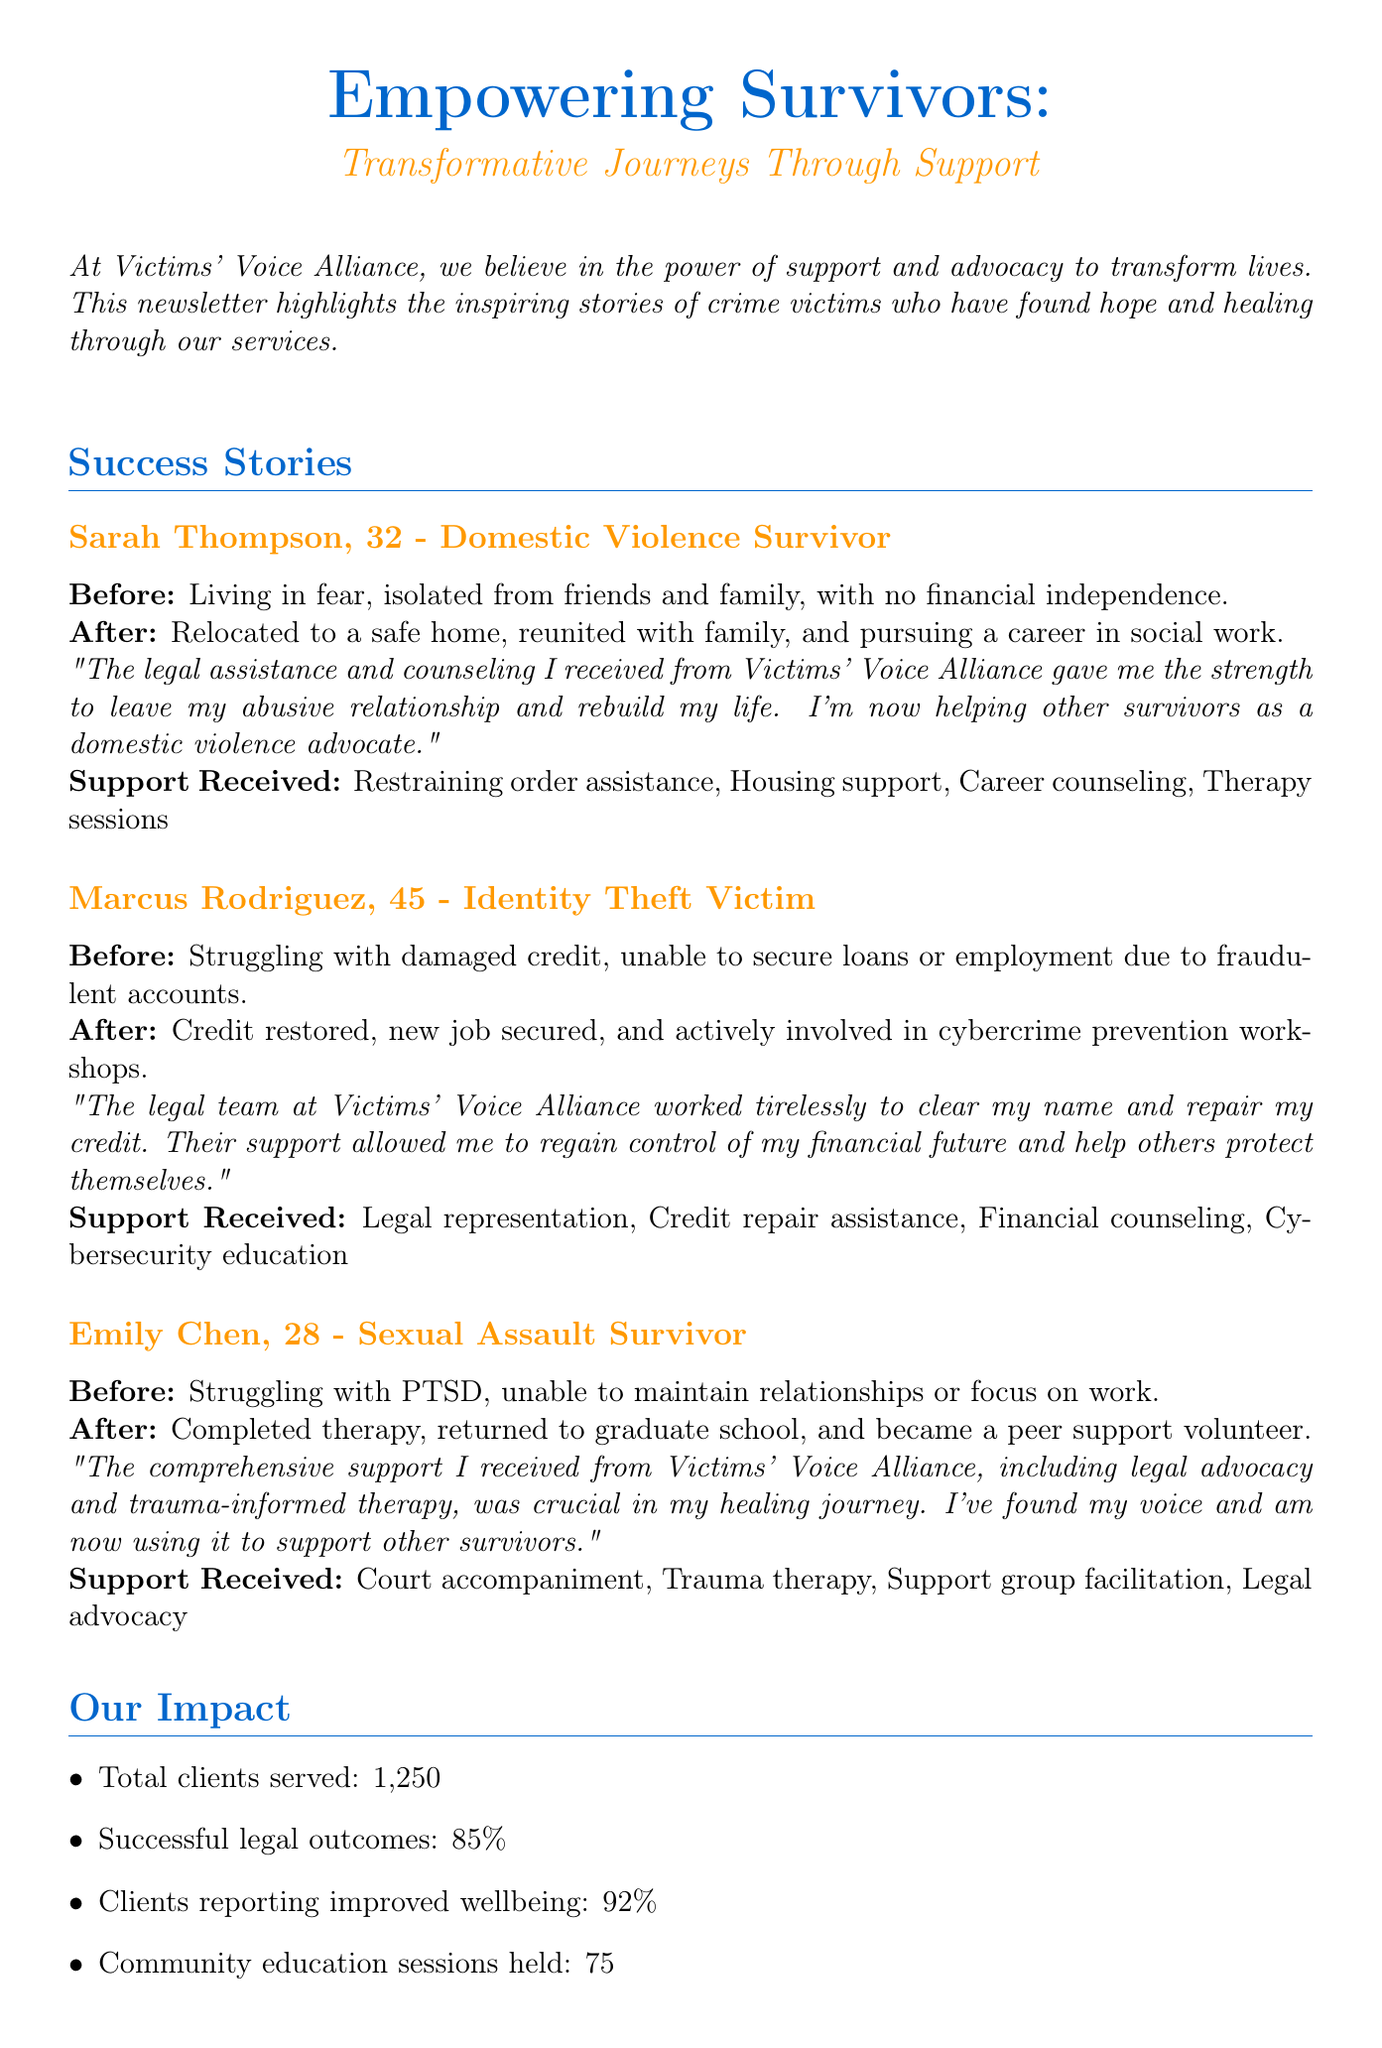What is the newsletter title? The newsletter title is mentioned at the top of the document's content.
Answer: Empowering Survivors: Transformative Journeys Through Support Who is a domestic violence survivor mentioned in the newsletter? The success stories highlight individuals who received support.
Answer: Sarah Thompson What age is Emily Chen? The age of Emily Chen is specified in the success stories section.
Answer: 28 What percentage of clients reported improved wellbeing? The impact statistics section provides specific percentages about client outcomes.
Answer: 92% What support did Marcus Rodriguez receive? The document lists specific types of support received by different survivors.
Answer: Legal representation, Credit repair assistance, Financial counseling, Cybersecurity education How many clients were served in total? The document explicitly states the total number of clients served.
Answer: 1250 What type of workshops does Marcus Rodriguez participate in after receiving support? This information is related to his activities after the support he received.
Answer: Cybercrime prevention workshops Name one partner organization listed in the collaborative efforts section. The document includes a list of partner organizations to highlight collaborative efforts.
Answer: Central City Police Department What type of volunteer opportunity is available according to the call to action? The call to action section outlines ways the community can assist the organization.
Answer: Legal clinic assistants 